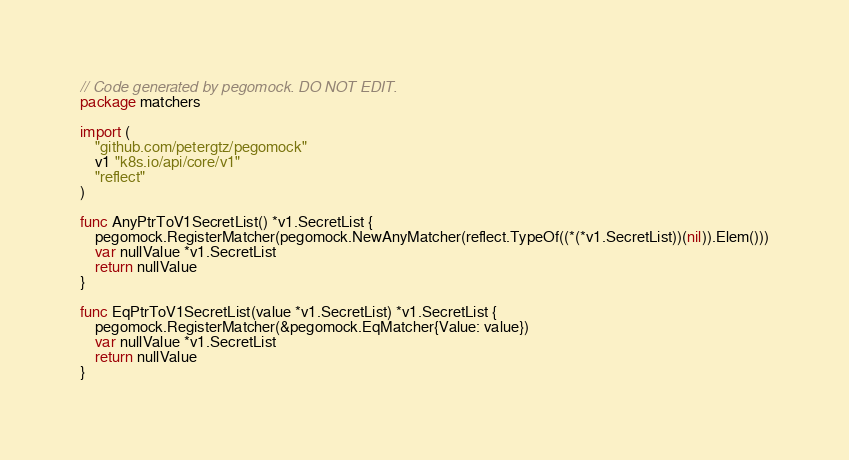Convert code to text. <code><loc_0><loc_0><loc_500><loc_500><_Go_>// Code generated by pegomock. DO NOT EDIT.
package matchers

import (
	"github.com/petergtz/pegomock"
	v1 "k8s.io/api/core/v1"
	"reflect"
)

func AnyPtrToV1SecretList() *v1.SecretList {
	pegomock.RegisterMatcher(pegomock.NewAnyMatcher(reflect.TypeOf((*(*v1.SecretList))(nil)).Elem()))
	var nullValue *v1.SecretList
	return nullValue
}

func EqPtrToV1SecretList(value *v1.SecretList) *v1.SecretList {
	pegomock.RegisterMatcher(&pegomock.EqMatcher{Value: value})
	var nullValue *v1.SecretList
	return nullValue
}
</code> 